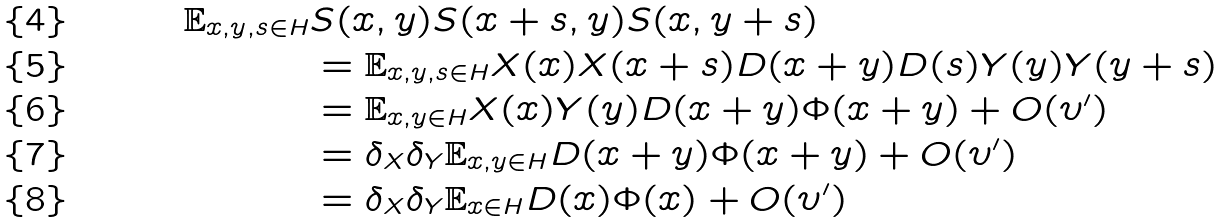<formula> <loc_0><loc_0><loc_500><loc_500>\mathbb { E } _ { x , y , s \in H } & S ( x , y ) S ( x + s , y ) S ( x , y + s ) \\ & = \mathbb { E } _ { x , y , s \in H } X ( x ) X ( x + s ) D ( x + y ) D ( s ) Y ( y ) Y ( y + s ) \\ & = \mathbb { E } _ { x , y \in H } X ( x ) Y ( y ) D ( x + y ) \Phi ( x + y ) + O ( \upsilon ^ { \prime } ) \\ & = \delta _ { X } \delta _ { Y } \mathbb { E } _ { x , y \in H } D ( x + y ) \Phi ( x + y ) + O ( \upsilon ^ { \prime } ) \\ & = \delta _ { X } \delta _ { Y } \mathbb { E } _ { x \in H } D ( x ) \Phi ( x ) + O ( \upsilon ^ { \prime } )</formula> 